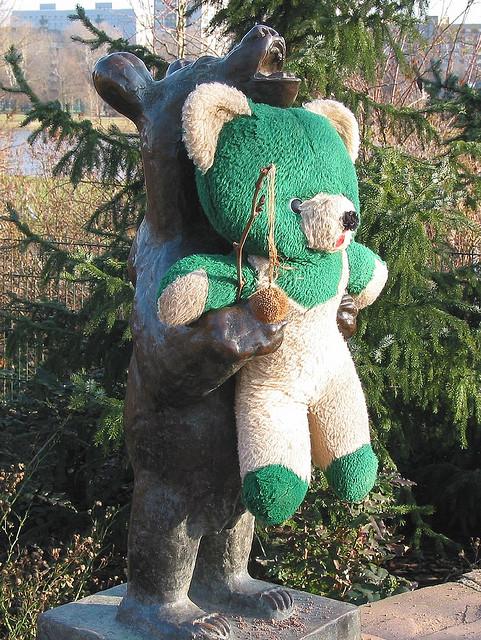Is the statue holding the bear a bear?
Give a very brief answer. Yes. Can you see trees in the picture?
Concise answer only. Yes. Is it daytime?
Quick response, please. Yes. 